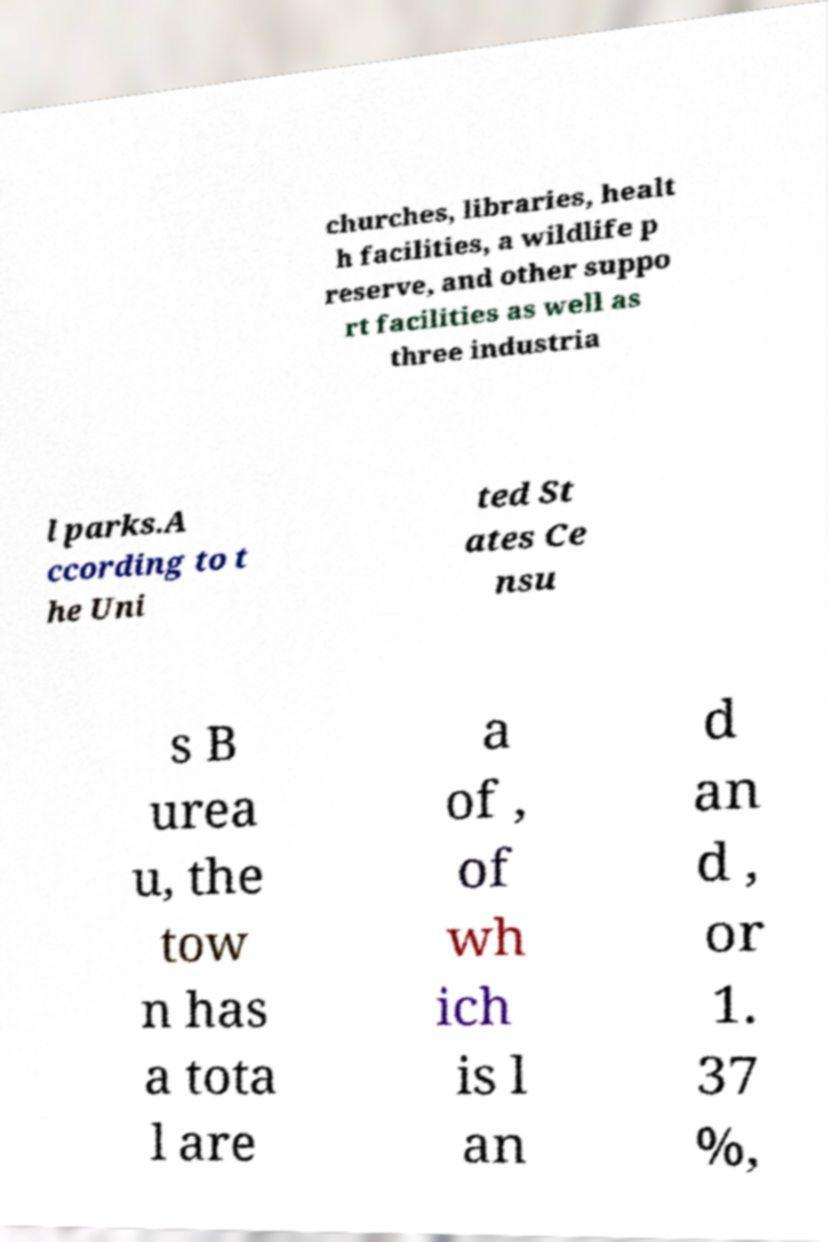Please identify and transcribe the text found in this image. churches, libraries, healt h facilities, a wildlife p reserve, and other suppo rt facilities as well as three industria l parks.A ccording to t he Uni ted St ates Ce nsu s B urea u, the tow n has a tota l are a of , of wh ich is l an d an d , or 1. 37 %, 